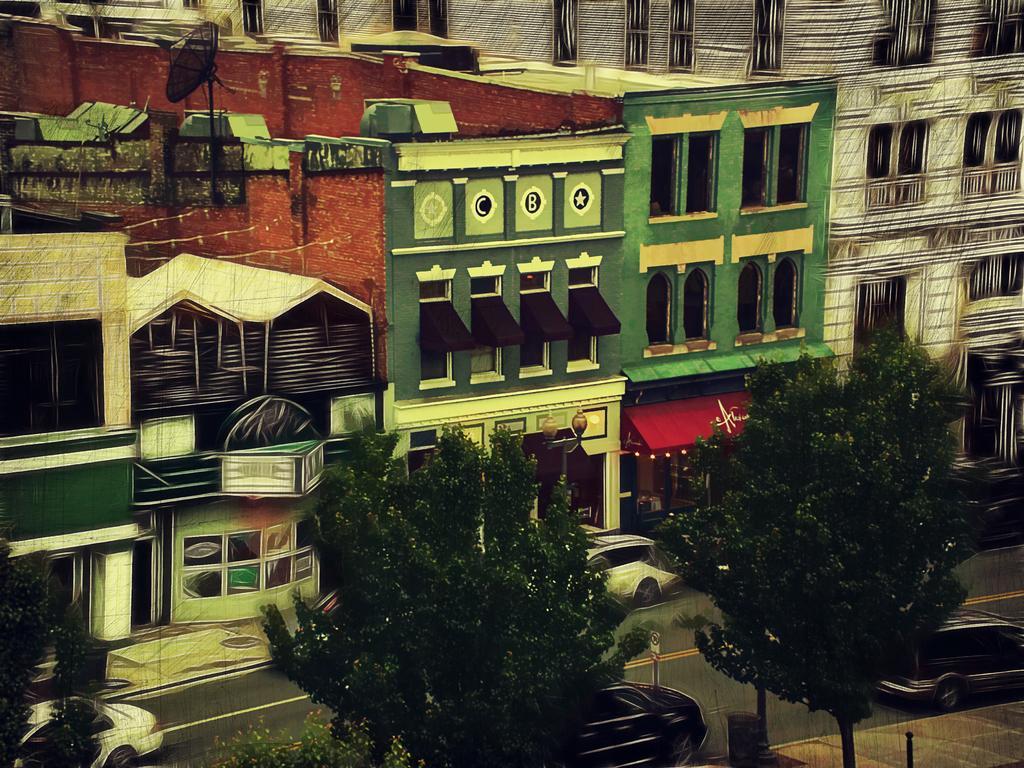Can you describe this image briefly? By seeing this image, we can say that this is a painting. There are lots of building here and lots of trees and cars over here. 